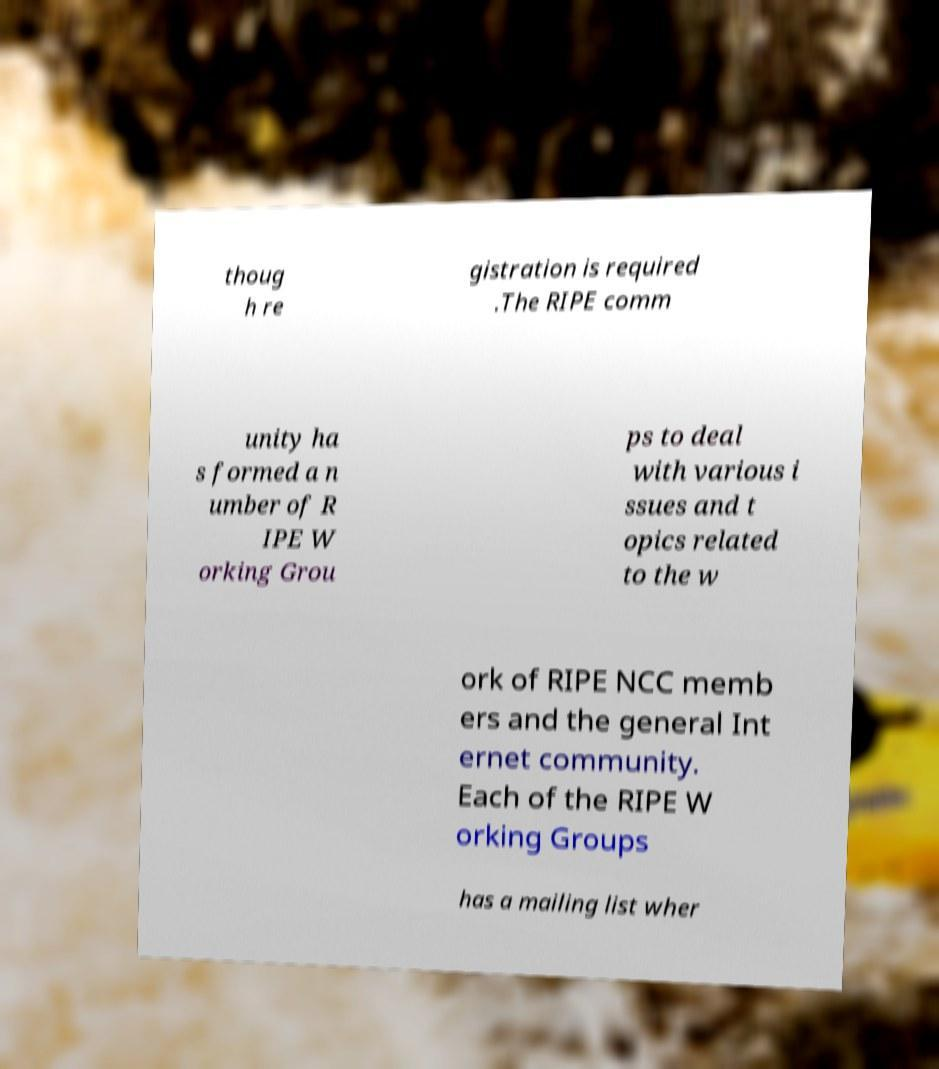Can you accurately transcribe the text from the provided image for me? thoug h re gistration is required .The RIPE comm unity ha s formed a n umber of R IPE W orking Grou ps to deal with various i ssues and t opics related to the w ork of RIPE NCC memb ers and the general Int ernet community. Each of the RIPE W orking Groups has a mailing list wher 